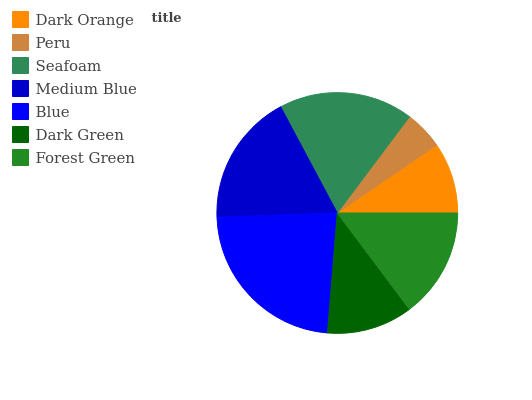Is Peru the minimum?
Answer yes or no. Yes. Is Blue the maximum?
Answer yes or no. Yes. Is Seafoam the minimum?
Answer yes or no. No. Is Seafoam the maximum?
Answer yes or no. No. Is Seafoam greater than Peru?
Answer yes or no. Yes. Is Peru less than Seafoam?
Answer yes or no. Yes. Is Peru greater than Seafoam?
Answer yes or no. No. Is Seafoam less than Peru?
Answer yes or no. No. Is Forest Green the high median?
Answer yes or no. Yes. Is Forest Green the low median?
Answer yes or no. Yes. Is Peru the high median?
Answer yes or no. No. Is Peru the low median?
Answer yes or no. No. 